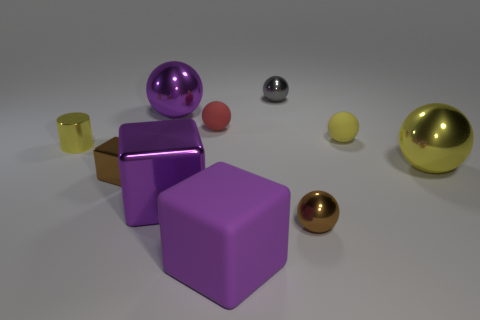Subtract all brown balls. How many balls are left? 5 Subtract 3 spheres. How many spheres are left? 3 Subtract all gray spheres. How many spheres are left? 5 Subtract all brown spheres. Subtract all yellow cylinders. How many spheres are left? 5 Subtract all blocks. How many objects are left? 7 Add 8 small cyan blocks. How many small cyan blocks exist? 8 Subtract 0 green spheres. How many objects are left? 10 Subtract all large yellow shiny spheres. Subtract all red matte balls. How many objects are left? 8 Add 3 metal cubes. How many metal cubes are left? 5 